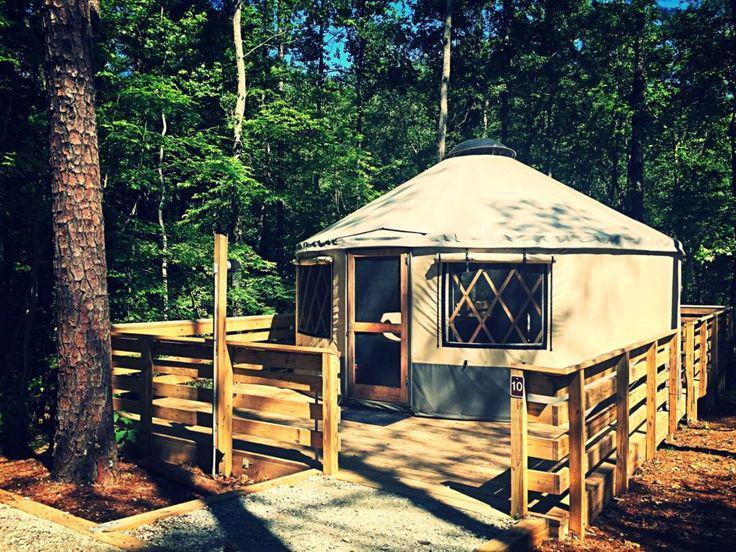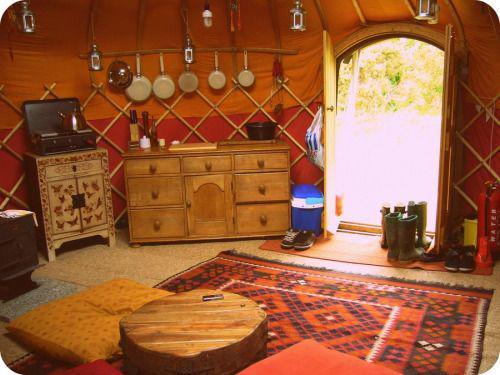The first image is the image on the left, the second image is the image on the right. Analyze the images presented: Is the assertion "One of the images is of the outside of a yurt, and the other is of the inside, and there is no snow visible in either of them." valid? Answer yes or no. Yes. 